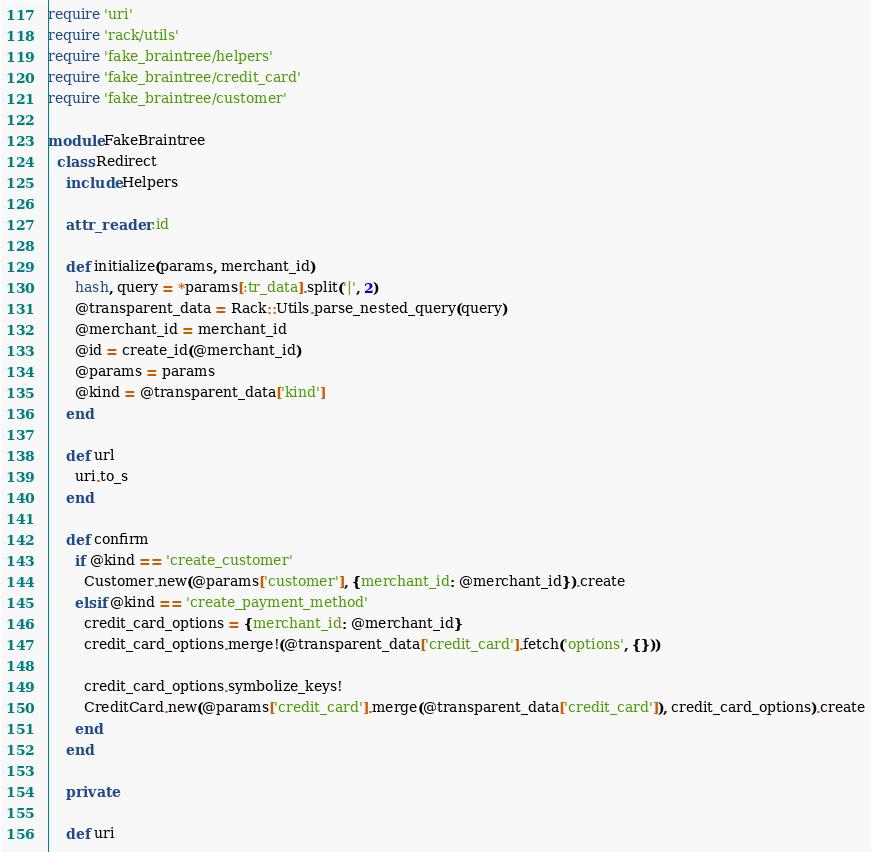<code> <loc_0><loc_0><loc_500><loc_500><_Ruby_>require 'uri'
require 'rack/utils'
require 'fake_braintree/helpers'
require 'fake_braintree/credit_card'
require 'fake_braintree/customer'

module FakeBraintree
  class Redirect
    include Helpers

    attr_reader :id

    def initialize(params, merchant_id)
      hash, query = *params[:tr_data].split('|', 2)
      @transparent_data = Rack::Utils.parse_nested_query(query)
      @merchant_id = merchant_id
      @id = create_id(@merchant_id)
      @params = params
      @kind = @transparent_data['kind']
    end

    def url
      uri.to_s
    end

    def confirm
      if @kind == 'create_customer'
        Customer.new(@params['customer'], {merchant_id: @merchant_id}).create
      elsif @kind == 'create_payment_method'
        credit_card_options = {merchant_id: @merchant_id}
        credit_card_options.merge!(@transparent_data['credit_card'].fetch('options', {}))

        credit_card_options.symbolize_keys!
        CreditCard.new(@params['credit_card'].merge(@transparent_data['credit_card']), credit_card_options).create
      end
    end

    private

    def uri</code> 